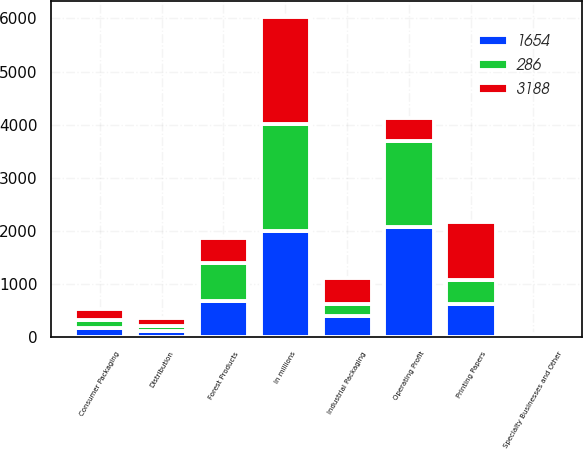<chart> <loc_0><loc_0><loc_500><loc_500><stacked_bar_chart><ecel><fcel>In millions<fcel>Printing Papers<fcel>Industrial Packaging<fcel>Consumer Packaging<fcel>Distribution<fcel>Forest Products<fcel>Specialty Businesses and Other<fcel>Operating Profit<nl><fcel>3188<fcel>2007<fcel>1101<fcel>501<fcel>198<fcel>146<fcel>471<fcel>6<fcel>434<nl><fcel>1654<fcel>2006<fcel>636<fcel>399<fcel>172<fcel>128<fcel>678<fcel>61<fcel>2074<nl><fcel>286<fcel>2005<fcel>434<fcel>219<fcel>160<fcel>84<fcel>721<fcel>4<fcel>1622<nl></chart> 